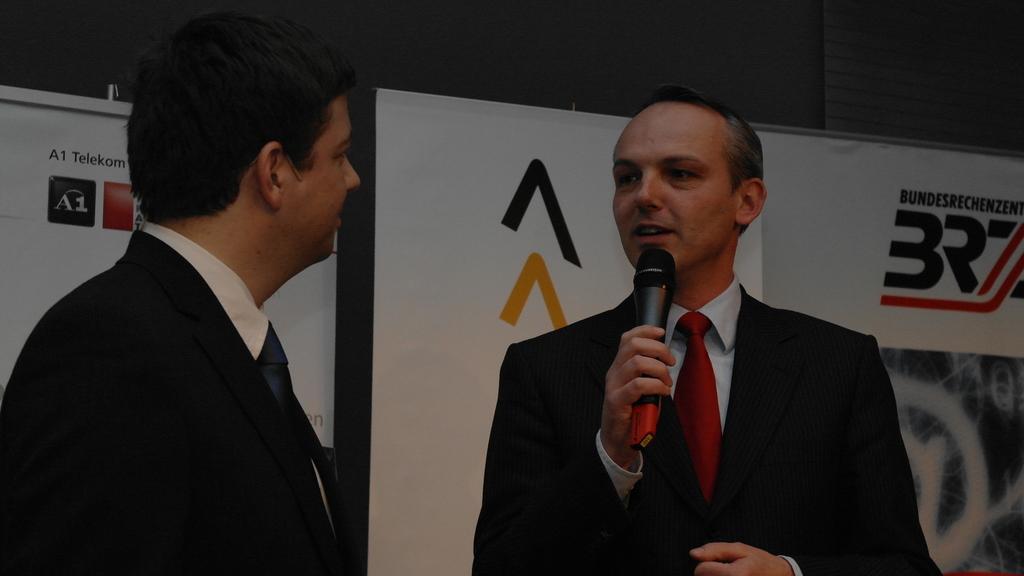Describe this image in one or two sentences. This is the picture of a place where we have two people wearing black suits, among them a person is holding the mic and behind there are two banners. 